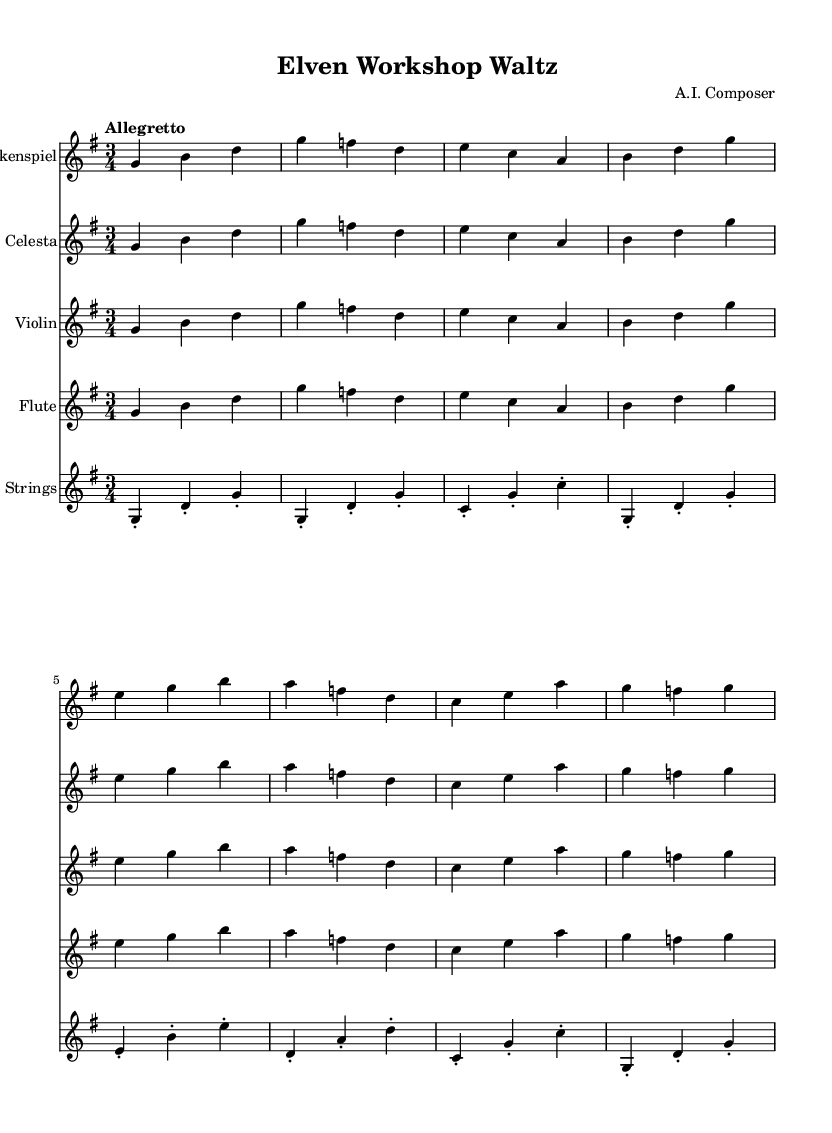What is the key signature of this music? The key signature is identified by checking the sharps and flats listed at the beginning of the staff. Here, it indicates one sharp, which corresponds to the key of G major.
Answer: G major What is the time signature of this composition? The time signature is displayed at the beginning of the music, showing how many beats are in each measure. This piece has three beats per measure, denoted as 3/4.
Answer: 3/4 What is the specified tempo for the piece? The tempo marking is found above the staff, indicating the speed at which the music should be played. Here, it states "Allegretto," which suggests a moderately quick pace.
Answer: Allegretto How many different instruments are scored in this piece? By counting the number of staves in the score, we see there are five different instruments: glockenspiel, celesta, violin, flute, and pizzicato strings.
Answer: Five Which instrument has the highest pitch range in this score? I examine the notes given for each instrument; the glockenspiel typically plays in a higher pitch range compared to the others. So, based on the notes, glockenspiel is the highest.
Answer: Glockenspiel What is the rhythmic pattern (note value) primarily used in the melody? Observing the notes shown, they are primarily quarter notes, indicated by their duration in the score. The repeating use of quarter notes throughout illustrates this.
Answer: Quarter notes What is the main theme of this piece based on its title? The title "Elven Workshop Waltz" suggests a whimsical and playful theme, as it evokes images of magical toy workshops and the joyful nature of elves.
Answer: Whimsical 